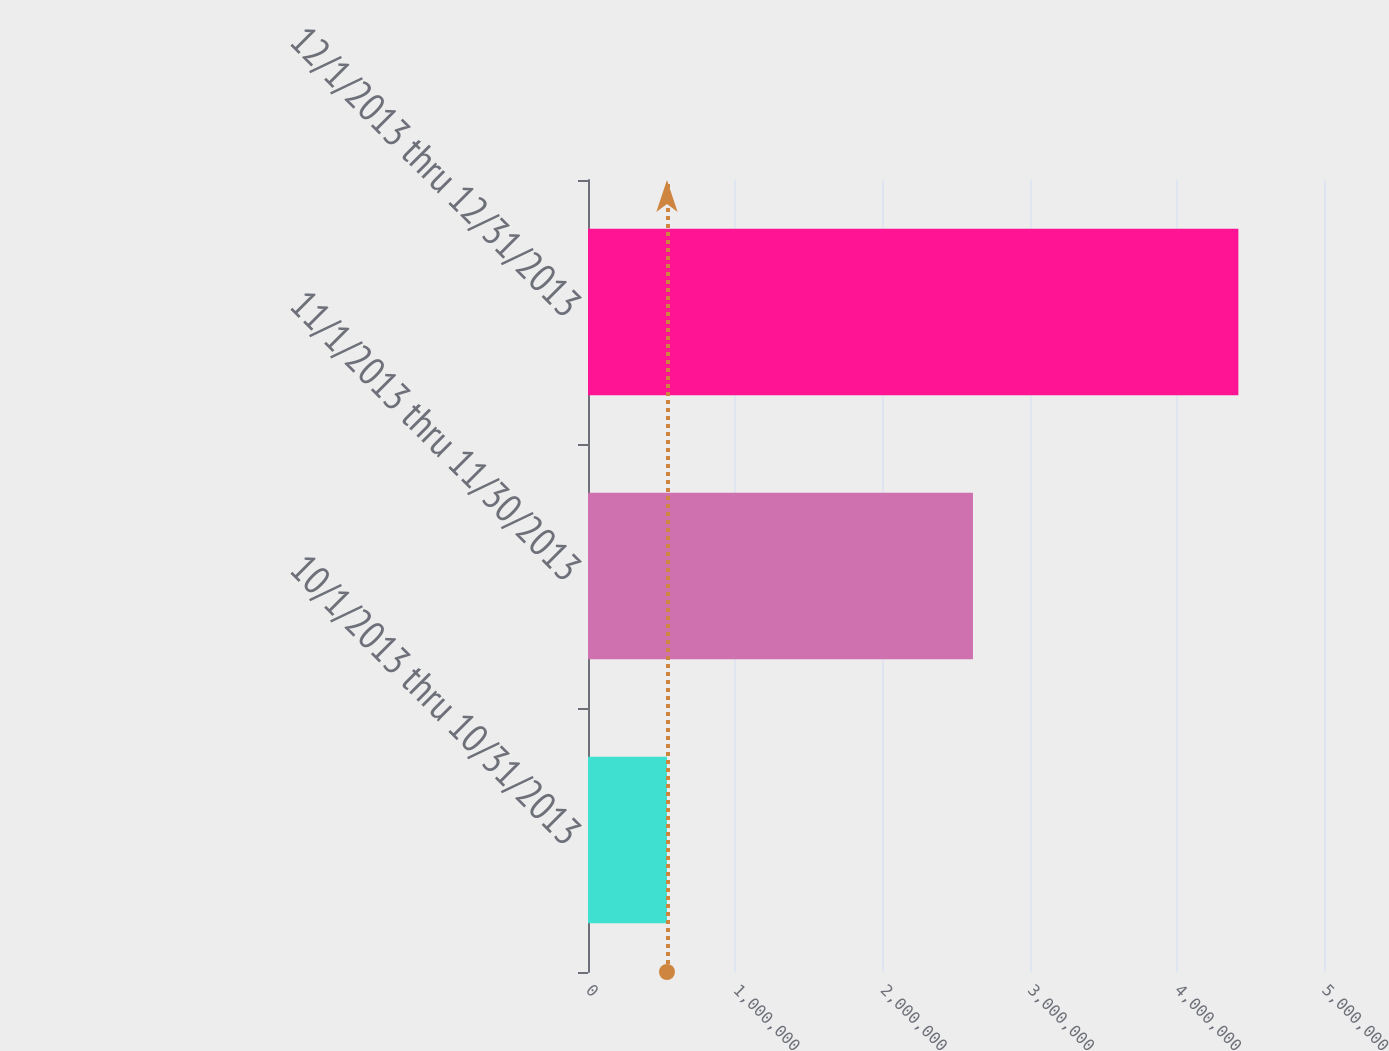Convert chart. <chart><loc_0><loc_0><loc_500><loc_500><bar_chart><fcel>10/1/2013 thru 10/31/2013<fcel>11/1/2013 thru 11/30/2013<fcel>12/1/2013 thru 12/31/2013<nl><fcel>536500<fcel>2.61528e+06<fcel>4.41837e+06<nl></chart> 